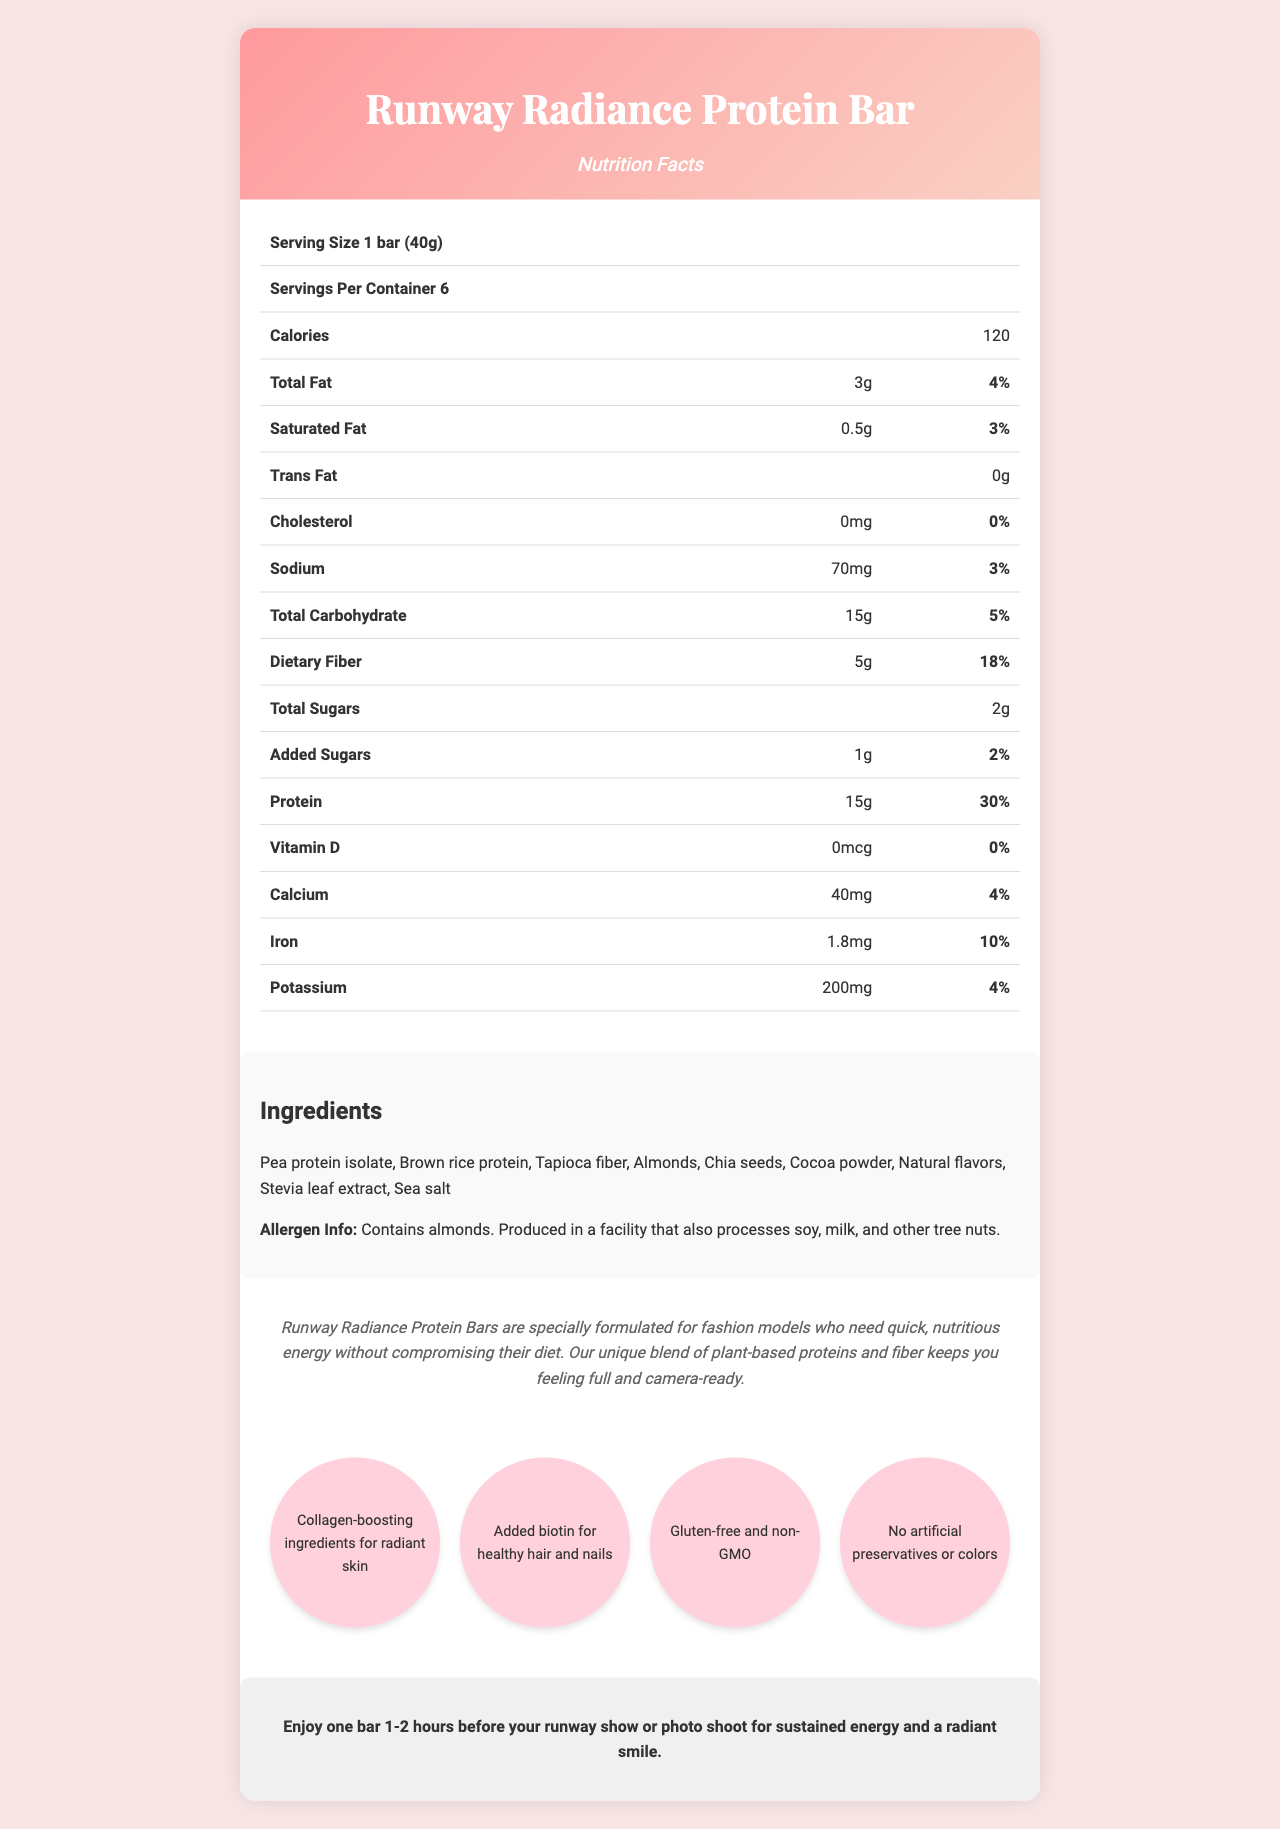what is the serving size? The document states that the serving size for the Runway Radiance Protein Bar is 1 bar, which weighs 40 grams.
Answer: 1 bar (40g) how many bars are there per container? The document mentions that there are 6 servings per container.
Answer: 6 how many grams of dietary fiber does the bar contain? According to the nutrition facts table, the dietary fiber content per serving is 5 grams.
Answer: 5g what is the percentage of daily value for protein? The document shows that the daily value percentage for protein is 30%.
Answer: 30% what type of protein is used in the ingredients? The ingredient list includes Pea protein isolate and Brown rice protein.
Answer: Pea protein isolate and Brown rice protein how many calories does one bar have? The nutrition facts table lists that each serving (1 bar) contains 120 calories.
Answer: 120 what are the collagen-boosting ingredients mentioned? A. Vitamin D and Calcium B. Biotin and Chia Seeds C. Collagen-boosting ingredients are not specified The document states that the bar has collagen-boosting ingredients, but it does not specify which ingredients they are.
Answer: C which ingredient is used as the sweetener? A. Stevia leaf extract B. Cocoa powder C. Sea salt D. Natural flavors Stevia leaf extract is the sweetener used, as indicated in the ingredient list.
Answer: A are there any trans fats in the bar? According to the nutrition facts table, the trans fat content is listed as 0g.
Answer: No is this product gluten-free? The document lists gluten-free as one of the model-specific features of the product.
Answer: Yes describe the recommended use of the product. The document provides the recommended use description in the dedicated section at the bottom.
Answer: Enjoy one bar 1-2 hours before your runway show or photo shoot for sustained energy and a radiant smile. what is the main allergen mentioned in the allergen info? The allergen information states that the product contains almonds.
Answer: Almonds does the bar contain any cholesterol? According to the nutrition facts table, the cholesterol content is 0mg, indicating no cholesterol.
Answer: No summarize the purpose and key features of Runway Radiance Protein Bar. The document highlights that the protein bar is specially formulated for models, providing essential nutrients and energy without compromising their diet. It also includes specific features beneficial for skin, hair, and nails.
Answer: The Runway Radiance Protein Bar is designed for fashion models who need quick, nutritious energy on-the-go. It is protein-packed, low-calorie, and includes collagen-boosting ingredients for radiant skin, biotin for healthy hair and nails, gluten-free, non-GMO, and free from artificial preservatives or colors. what are the exact benefits provided by the added biotin in the bar? The document states that biotin is added for healthy hair and nails but does not provide specific benefits or quantities.
Answer: Cannot be determined how much calcium does one bar contain? The nutrition facts table indicates that each serving contains 40mg of calcium.
Answer: 40mg 